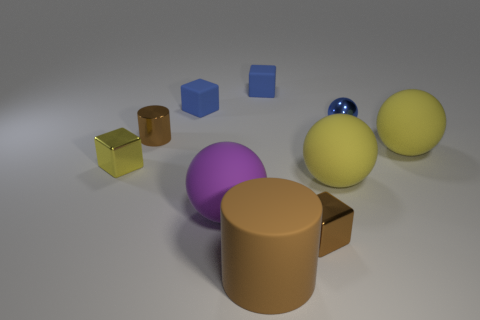Subtract 1 blocks. How many blocks are left? 3 Subtract all cylinders. How many objects are left? 8 Add 6 rubber blocks. How many rubber blocks exist? 8 Subtract 0 red balls. How many objects are left? 10 Subtract all yellow spheres. Subtract all large cylinders. How many objects are left? 7 Add 6 blue blocks. How many blue blocks are left? 8 